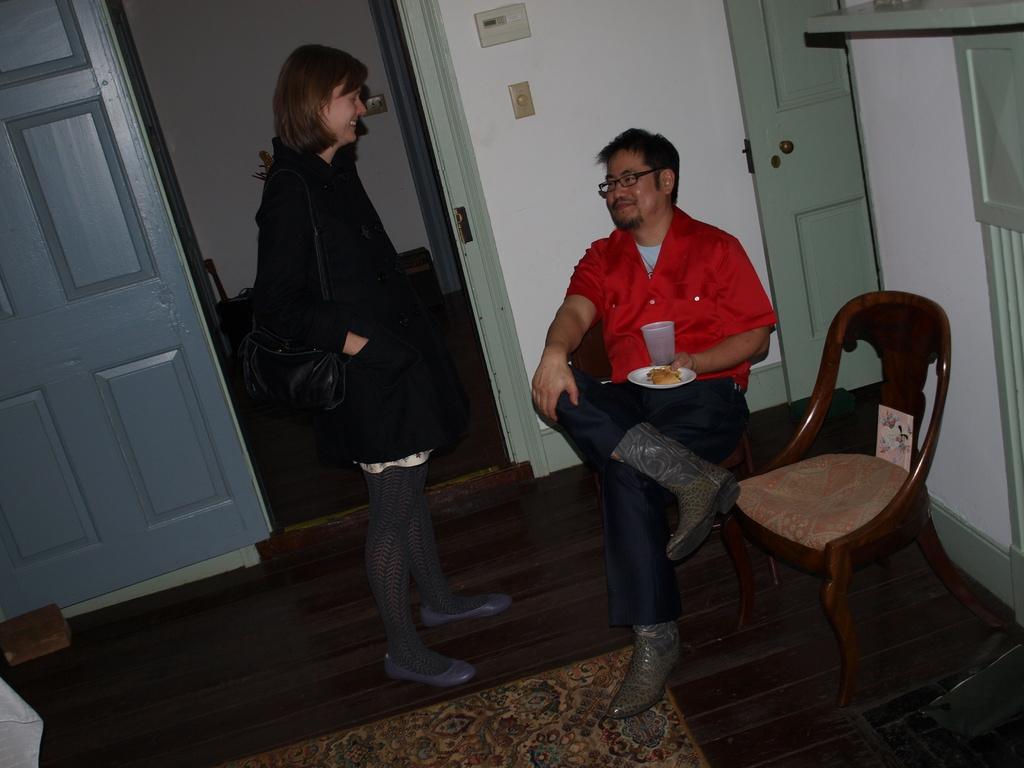How would you summarize this image in a sentence or two? In the image we see there are two people in a room a man is sitting and the woman is standing. 